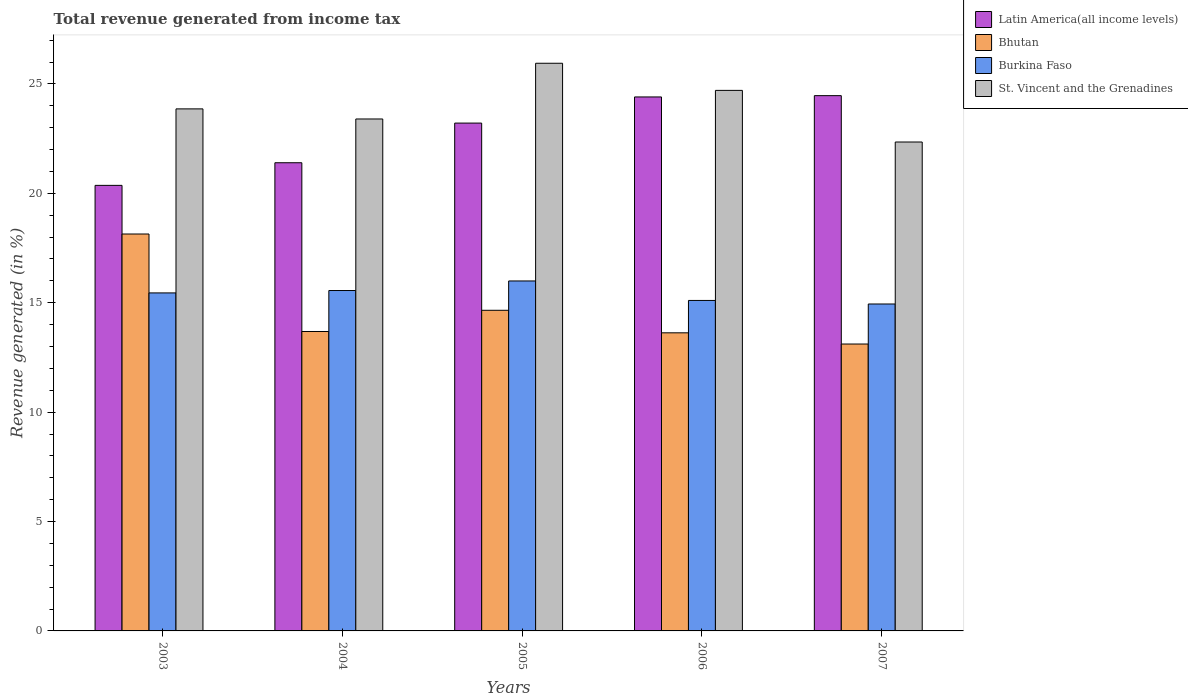How many different coloured bars are there?
Give a very brief answer. 4. Are the number of bars per tick equal to the number of legend labels?
Your answer should be compact. Yes. How many bars are there on the 2nd tick from the left?
Make the answer very short. 4. How many bars are there on the 3rd tick from the right?
Give a very brief answer. 4. In how many cases, is the number of bars for a given year not equal to the number of legend labels?
Your answer should be very brief. 0. What is the total revenue generated in Bhutan in 2007?
Your answer should be very brief. 13.11. Across all years, what is the maximum total revenue generated in Bhutan?
Your answer should be compact. 18.14. Across all years, what is the minimum total revenue generated in Burkina Faso?
Ensure brevity in your answer.  14.94. In which year was the total revenue generated in St. Vincent and the Grenadines maximum?
Make the answer very short. 2005. What is the total total revenue generated in Burkina Faso in the graph?
Your answer should be compact. 77.05. What is the difference between the total revenue generated in St. Vincent and the Grenadines in 2004 and that in 2005?
Give a very brief answer. -2.55. What is the difference between the total revenue generated in Burkina Faso in 2006 and the total revenue generated in St. Vincent and the Grenadines in 2004?
Ensure brevity in your answer.  -8.29. What is the average total revenue generated in Latin America(all income levels) per year?
Ensure brevity in your answer.  22.77. In the year 2004, what is the difference between the total revenue generated in Latin America(all income levels) and total revenue generated in St. Vincent and the Grenadines?
Ensure brevity in your answer.  -2. What is the ratio of the total revenue generated in Burkina Faso in 2004 to that in 2005?
Your response must be concise. 0.97. Is the difference between the total revenue generated in Latin America(all income levels) in 2003 and 2005 greater than the difference between the total revenue generated in St. Vincent and the Grenadines in 2003 and 2005?
Make the answer very short. No. What is the difference between the highest and the second highest total revenue generated in Latin America(all income levels)?
Ensure brevity in your answer.  0.06. What is the difference between the highest and the lowest total revenue generated in St. Vincent and the Grenadines?
Ensure brevity in your answer.  3.6. In how many years, is the total revenue generated in Bhutan greater than the average total revenue generated in Bhutan taken over all years?
Ensure brevity in your answer.  2. What does the 1st bar from the left in 2007 represents?
Keep it short and to the point. Latin America(all income levels). What does the 1st bar from the right in 2004 represents?
Your response must be concise. St. Vincent and the Grenadines. How many bars are there?
Your response must be concise. 20. How many years are there in the graph?
Your answer should be compact. 5. Are the values on the major ticks of Y-axis written in scientific E-notation?
Ensure brevity in your answer.  No. How are the legend labels stacked?
Ensure brevity in your answer.  Vertical. What is the title of the graph?
Give a very brief answer. Total revenue generated from income tax. What is the label or title of the Y-axis?
Your response must be concise. Revenue generated (in %). What is the Revenue generated (in %) of Latin America(all income levels) in 2003?
Give a very brief answer. 20.36. What is the Revenue generated (in %) of Bhutan in 2003?
Your response must be concise. 18.14. What is the Revenue generated (in %) in Burkina Faso in 2003?
Make the answer very short. 15.45. What is the Revenue generated (in %) of St. Vincent and the Grenadines in 2003?
Keep it short and to the point. 23.86. What is the Revenue generated (in %) of Latin America(all income levels) in 2004?
Offer a very short reply. 21.4. What is the Revenue generated (in %) in Bhutan in 2004?
Provide a succinct answer. 13.69. What is the Revenue generated (in %) of Burkina Faso in 2004?
Offer a terse response. 15.56. What is the Revenue generated (in %) of St. Vincent and the Grenadines in 2004?
Keep it short and to the point. 23.4. What is the Revenue generated (in %) in Latin America(all income levels) in 2005?
Provide a short and direct response. 23.21. What is the Revenue generated (in %) of Bhutan in 2005?
Offer a very short reply. 14.65. What is the Revenue generated (in %) of Burkina Faso in 2005?
Offer a terse response. 16. What is the Revenue generated (in %) in St. Vincent and the Grenadines in 2005?
Make the answer very short. 25.95. What is the Revenue generated (in %) in Latin America(all income levels) in 2006?
Your answer should be very brief. 24.41. What is the Revenue generated (in %) of Bhutan in 2006?
Your response must be concise. 13.63. What is the Revenue generated (in %) in Burkina Faso in 2006?
Your response must be concise. 15.11. What is the Revenue generated (in %) of St. Vincent and the Grenadines in 2006?
Make the answer very short. 24.71. What is the Revenue generated (in %) in Latin America(all income levels) in 2007?
Ensure brevity in your answer.  24.47. What is the Revenue generated (in %) in Bhutan in 2007?
Provide a short and direct response. 13.11. What is the Revenue generated (in %) of Burkina Faso in 2007?
Your answer should be very brief. 14.94. What is the Revenue generated (in %) of St. Vincent and the Grenadines in 2007?
Your answer should be compact. 22.35. Across all years, what is the maximum Revenue generated (in %) in Latin America(all income levels)?
Provide a short and direct response. 24.47. Across all years, what is the maximum Revenue generated (in %) of Bhutan?
Offer a terse response. 18.14. Across all years, what is the maximum Revenue generated (in %) in Burkina Faso?
Ensure brevity in your answer.  16. Across all years, what is the maximum Revenue generated (in %) of St. Vincent and the Grenadines?
Your answer should be compact. 25.95. Across all years, what is the minimum Revenue generated (in %) of Latin America(all income levels)?
Ensure brevity in your answer.  20.36. Across all years, what is the minimum Revenue generated (in %) in Bhutan?
Provide a short and direct response. 13.11. Across all years, what is the minimum Revenue generated (in %) of Burkina Faso?
Your answer should be very brief. 14.94. Across all years, what is the minimum Revenue generated (in %) of St. Vincent and the Grenadines?
Your response must be concise. 22.35. What is the total Revenue generated (in %) of Latin America(all income levels) in the graph?
Your response must be concise. 113.85. What is the total Revenue generated (in %) in Bhutan in the graph?
Your response must be concise. 73.22. What is the total Revenue generated (in %) of Burkina Faso in the graph?
Keep it short and to the point. 77.05. What is the total Revenue generated (in %) of St. Vincent and the Grenadines in the graph?
Give a very brief answer. 120.26. What is the difference between the Revenue generated (in %) in Latin America(all income levels) in 2003 and that in 2004?
Your response must be concise. -1.03. What is the difference between the Revenue generated (in %) of Bhutan in 2003 and that in 2004?
Ensure brevity in your answer.  4.46. What is the difference between the Revenue generated (in %) in Burkina Faso in 2003 and that in 2004?
Your answer should be very brief. -0.11. What is the difference between the Revenue generated (in %) in St. Vincent and the Grenadines in 2003 and that in 2004?
Offer a terse response. 0.46. What is the difference between the Revenue generated (in %) of Latin America(all income levels) in 2003 and that in 2005?
Offer a very short reply. -2.85. What is the difference between the Revenue generated (in %) of Bhutan in 2003 and that in 2005?
Provide a succinct answer. 3.49. What is the difference between the Revenue generated (in %) of Burkina Faso in 2003 and that in 2005?
Your response must be concise. -0.55. What is the difference between the Revenue generated (in %) of St. Vincent and the Grenadines in 2003 and that in 2005?
Ensure brevity in your answer.  -2.09. What is the difference between the Revenue generated (in %) of Latin America(all income levels) in 2003 and that in 2006?
Ensure brevity in your answer.  -4.04. What is the difference between the Revenue generated (in %) in Bhutan in 2003 and that in 2006?
Ensure brevity in your answer.  4.52. What is the difference between the Revenue generated (in %) of Burkina Faso in 2003 and that in 2006?
Keep it short and to the point. 0.34. What is the difference between the Revenue generated (in %) in St. Vincent and the Grenadines in 2003 and that in 2006?
Provide a short and direct response. -0.84. What is the difference between the Revenue generated (in %) of Latin America(all income levels) in 2003 and that in 2007?
Your answer should be very brief. -4.1. What is the difference between the Revenue generated (in %) of Bhutan in 2003 and that in 2007?
Offer a very short reply. 5.03. What is the difference between the Revenue generated (in %) in Burkina Faso in 2003 and that in 2007?
Offer a very short reply. 0.51. What is the difference between the Revenue generated (in %) of St. Vincent and the Grenadines in 2003 and that in 2007?
Your response must be concise. 1.51. What is the difference between the Revenue generated (in %) in Latin America(all income levels) in 2004 and that in 2005?
Ensure brevity in your answer.  -1.81. What is the difference between the Revenue generated (in %) in Bhutan in 2004 and that in 2005?
Give a very brief answer. -0.97. What is the difference between the Revenue generated (in %) of Burkina Faso in 2004 and that in 2005?
Keep it short and to the point. -0.44. What is the difference between the Revenue generated (in %) in St. Vincent and the Grenadines in 2004 and that in 2005?
Make the answer very short. -2.55. What is the difference between the Revenue generated (in %) of Latin America(all income levels) in 2004 and that in 2006?
Provide a succinct answer. -3.01. What is the difference between the Revenue generated (in %) of Bhutan in 2004 and that in 2006?
Make the answer very short. 0.06. What is the difference between the Revenue generated (in %) in Burkina Faso in 2004 and that in 2006?
Your answer should be very brief. 0.45. What is the difference between the Revenue generated (in %) of St. Vincent and the Grenadines in 2004 and that in 2006?
Offer a terse response. -1.31. What is the difference between the Revenue generated (in %) in Latin America(all income levels) in 2004 and that in 2007?
Your answer should be very brief. -3.07. What is the difference between the Revenue generated (in %) of Bhutan in 2004 and that in 2007?
Ensure brevity in your answer.  0.57. What is the difference between the Revenue generated (in %) in Burkina Faso in 2004 and that in 2007?
Provide a short and direct response. 0.62. What is the difference between the Revenue generated (in %) of St. Vincent and the Grenadines in 2004 and that in 2007?
Provide a short and direct response. 1.05. What is the difference between the Revenue generated (in %) in Latin America(all income levels) in 2005 and that in 2006?
Your answer should be compact. -1.19. What is the difference between the Revenue generated (in %) of Bhutan in 2005 and that in 2006?
Offer a very short reply. 1.03. What is the difference between the Revenue generated (in %) in Burkina Faso in 2005 and that in 2006?
Provide a short and direct response. 0.89. What is the difference between the Revenue generated (in %) of St. Vincent and the Grenadines in 2005 and that in 2006?
Provide a short and direct response. 1.24. What is the difference between the Revenue generated (in %) of Latin America(all income levels) in 2005 and that in 2007?
Ensure brevity in your answer.  -1.25. What is the difference between the Revenue generated (in %) in Bhutan in 2005 and that in 2007?
Your answer should be very brief. 1.54. What is the difference between the Revenue generated (in %) in Burkina Faso in 2005 and that in 2007?
Give a very brief answer. 1.05. What is the difference between the Revenue generated (in %) in St. Vincent and the Grenadines in 2005 and that in 2007?
Your answer should be very brief. 3.6. What is the difference between the Revenue generated (in %) of Latin America(all income levels) in 2006 and that in 2007?
Offer a very short reply. -0.06. What is the difference between the Revenue generated (in %) in Bhutan in 2006 and that in 2007?
Offer a terse response. 0.51. What is the difference between the Revenue generated (in %) of Burkina Faso in 2006 and that in 2007?
Provide a succinct answer. 0.16. What is the difference between the Revenue generated (in %) in St. Vincent and the Grenadines in 2006 and that in 2007?
Your response must be concise. 2.36. What is the difference between the Revenue generated (in %) of Latin America(all income levels) in 2003 and the Revenue generated (in %) of Bhutan in 2004?
Offer a very short reply. 6.68. What is the difference between the Revenue generated (in %) of Latin America(all income levels) in 2003 and the Revenue generated (in %) of Burkina Faso in 2004?
Your answer should be very brief. 4.81. What is the difference between the Revenue generated (in %) of Latin America(all income levels) in 2003 and the Revenue generated (in %) of St. Vincent and the Grenadines in 2004?
Provide a succinct answer. -3.03. What is the difference between the Revenue generated (in %) of Bhutan in 2003 and the Revenue generated (in %) of Burkina Faso in 2004?
Your answer should be compact. 2.58. What is the difference between the Revenue generated (in %) of Bhutan in 2003 and the Revenue generated (in %) of St. Vincent and the Grenadines in 2004?
Keep it short and to the point. -5.26. What is the difference between the Revenue generated (in %) in Burkina Faso in 2003 and the Revenue generated (in %) in St. Vincent and the Grenadines in 2004?
Offer a terse response. -7.95. What is the difference between the Revenue generated (in %) of Latin America(all income levels) in 2003 and the Revenue generated (in %) of Bhutan in 2005?
Your response must be concise. 5.71. What is the difference between the Revenue generated (in %) of Latin America(all income levels) in 2003 and the Revenue generated (in %) of Burkina Faso in 2005?
Provide a short and direct response. 4.37. What is the difference between the Revenue generated (in %) in Latin America(all income levels) in 2003 and the Revenue generated (in %) in St. Vincent and the Grenadines in 2005?
Offer a very short reply. -5.58. What is the difference between the Revenue generated (in %) of Bhutan in 2003 and the Revenue generated (in %) of Burkina Faso in 2005?
Offer a very short reply. 2.15. What is the difference between the Revenue generated (in %) in Bhutan in 2003 and the Revenue generated (in %) in St. Vincent and the Grenadines in 2005?
Make the answer very short. -7.8. What is the difference between the Revenue generated (in %) in Burkina Faso in 2003 and the Revenue generated (in %) in St. Vincent and the Grenadines in 2005?
Keep it short and to the point. -10.5. What is the difference between the Revenue generated (in %) of Latin America(all income levels) in 2003 and the Revenue generated (in %) of Bhutan in 2006?
Provide a succinct answer. 6.74. What is the difference between the Revenue generated (in %) of Latin America(all income levels) in 2003 and the Revenue generated (in %) of Burkina Faso in 2006?
Ensure brevity in your answer.  5.26. What is the difference between the Revenue generated (in %) of Latin America(all income levels) in 2003 and the Revenue generated (in %) of St. Vincent and the Grenadines in 2006?
Ensure brevity in your answer.  -4.34. What is the difference between the Revenue generated (in %) in Bhutan in 2003 and the Revenue generated (in %) in Burkina Faso in 2006?
Make the answer very short. 3.04. What is the difference between the Revenue generated (in %) of Bhutan in 2003 and the Revenue generated (in %) of St. Vincent and the Grenadines in 2006?
Provide a short and direct response. -6.56. What is the difference between the Revenue generated (in %) in Burkina Faso in 2003 and the Revenue generated (in %) in St. Vincent and the Grenadines in 2006?
Give a very brief answer. -9.26. What is the difference between the Revenue generated (in %) in Latin America(all income levels) in 2003 and the Revenue generated (in %) in Bhutan in 2007?
Provide a succinct answer. 7.25. What is the difference between the Revenue generated (in %) in Latin America(all income levels) in 2003 and the Revenue generated (in %) in Burkina Faso in 2007?
Ensure brevity in your answer.  5.42. What is the difference between the Revenue generated (in %) in Latin America(all income levels) in 2003 and the Revenue generated (in %) in St. Vincent and the Grenadines in 2007?
Provide a succinct answer. -1.98. What is the difference between the Revenue generated (in %) in Bhutan in 2003 and the Revenue generated (in %) in Burkina Faso in 2007?
Your response must be concise. 3.2. What is the difference between the Revenue generated (in %) in Bhutan in 2003 and the Revenue generated (in %) in St. Vincent and the Grenadines in 2007?
Your answer should be compact. -4.21. What is the difference between the Revenue generated (in %) of Burkina Faso in 2003 and the Revenue generated (in %) of St. Vincent and the Grenadines in 2007?
Offer a very short reply. -6.9. What is the difference between the Revenue generated (in %) of Latin America(all income levels) in 2004 and the Revenue generated (in %) of Bhutan in 2005?
Provide a succinct answer. 6.74. What is the difference between the Revenue generated (in %) of Latin America(all income levels) in 2004 and the Revenue generated (in %) of Burkina Faso in 2005?
Give a very brief answer. 5.4. What is the difference between the Revenue generated (in %) in Latin America(all income levels) in 2004 and the Revenue generated (in %) in St. Vincent and the Grenadines in 2005?
Offer a very short reply. -4.55. What is the difference between the Revenue generated (in %) in Bhutan in 2004 and the Revenue generated (in %) in Burkina Faso in 2005?
Give a very brief answer. -2.31. What is the difference between the Revenue generated (in %) in Bhutan in 2004 and the Revenue generated (in %) in St. Vincent and the Grenadines in 2005?
Your response must be concise. -12.26. What is the difference between the Revenue generated (in %) in Burkina Faso in 2004 and the Revenue generated (in %) in St. Vincent and the Grenadines in 2005?
Make the answer very short. -10.39. What is the difference between the Revenue generated (in %) of Latin America(all income levels) in 2004 and the Revenue generated (in %) of Bhutan in 2006?
Offer a very short reply. 7.77. What is the difference between the Revenue generated (in %) in Latin America(all income levels) in 2004 and the Revenue generated (in %) in Burkina Faso in 2006?
Keep it short and to the point. 6.29. What is the difference between the Revenue generated (in %) of Latin America(all income levels) in 2004 and the Revenue generated (in %) of St. Vincent and the Grenadines in 2006?
Your answer should be compact. -3.31. What is the difference between the Revenue generated (in %) in Bhutan in 2004 and the Revenue generated (in %) in Burkina Faso in 2006?
Offer a terse response. -1.42. What is the difference between the Revenue generated (in %) in Bhutan in 2004 and the Revenue generated (in %) in St. Vincent and the Grenadines in 2006?
Provide a short and direct response. -11.02. What is the difference between the Revenue generated (in %) of Burkina Faso in 2004 and the Revenue generated (in %) of St. Vincent and the Grenadines in 2006?
Ensure brevity in your answer.  -9.15. What is the difference between the Revenue generated (in %) of Latin America(all income levels) in 2004 and the Revenue generated (in %) of Bhutan in 2007?
Ensure brevity in your answer.  8.29. What is the difference between the Revenue generated (in %) in Latin America(all income levels) in 2004 and the Revenue generated (in %) in Burkina Faso in 2007?
Make the answer very short. 6.46. What is the difference between the Revenue generated (in %) of Latin America(all income levels) in 2004 and the Revenue generated (in %) of St. Vincent and the Grenadines in 2007?
Keep it short and to the point. -0.95. What is the difference between the Revenue generated (in %) in Bhutan in 2004 and the Revenue generated (in %) in Burkina Faso in 2007?
Keep it short and to the point. -1.26. What is the difference between the Revenue generated (in %) in Bhutan in 2004 and the Revenue generated (in %) in St. Vincent and the Grenadines in 2007?
Give a very brief answer. -8.66. What is the difference between the Revenue generated (in %) in Burkina Faso in 2004 and the Revenue generated (in %) in St. Vincent and the Grenadines in 2007?
Your response must be concise. -6.79. What is the difference between the Revenue generated (in %) in Latin America(all income levels) in 2005 and the Revenue generated (in %) in Bhutan in 2006?
Make the answer very short. 9.59. What is the difference between the Revenue generated (in %) in Latin America(all income levels) in 2005 and the Revenue generated (in %) in Burkina Faso in 2006?
Make the answer very short. 8.11. What is the difference between the Revenue generated (in %) in Latin America(all income levels) in 2005 and the Revenue generated (in %) in St. Vincent and the Grenadines in 2006?
Give a very brief answer. -1.49. What is the difference between the Revenue generated (in %) in Bhutan in 2005 and the Revenue generated (in %) in Burkina Faso in 2006?
Offer a very short reply. -0.45. What is the difference between the Revenue generated (in %) of Bhutan in 2005 and the Revenue generated (in %) of St. Vincent and the Grenadines in 2006?
Provide a succinct answer. -10.05. What is the difference between the Revenue generated (in %) in Burkina Faso in 2005 and the Revenue generated (in %) in St. Vincent and the Grenadines in 2006?
Provide a short and direct response. -8.71. What is the difference between the Revenue generated (in %) in Latin America(all income levels) in 2005 and the Revenue generated (in %) in Bhutan in 2007?
Ensure brevity in your answer.  10.1. What is the difference between the Revenue generated (in %) of Latin America(all income levels) in 2005 and the Revenue generated (in %) of Burkina Faso in 2007?
Make the answer very short. 8.27. What is the difference between the Revenue generated (in %) of Latin America(all income levels) in 2005 and the Revenue generated (in %) of St. Vincent and the Grenadines in 2007?
Keep it short and to the point. 0.86. What is the difference between the Revenue generated (in %) of Bhutan in 2005 and the Revenue generated (in %) of Burkina Faso in 2007?
Your answer should be compact. -0.29. What is the difference between the Revenue generated (in %) of Bhutan in 2005 and the Revenue generated (in %) of St. Vincent and the Grenadines in 2007?
Offer a very short reply. -7.69. What is the difference between the Revenue generated (in %) of Burkina Faso in 2005 and the Revenue generated (in %) of St. Vincent and the Grenadines in 2007?
Make the answer very short. -6.35. What is the difference between the Revenue generated (in %) of Latin America(all income levels) in 2006 and the Revenue generated (in %) of Bhutan in 2007?
Your answer should be compact. 11.29. What is the difference between the Revenue generated (in %) of Latin America(all income levels) in 2006 and the Revenue generated (in %) of Burkina Faso in 2007?
Provide a succinct answer. 9.46. What is the difference between the Revenue generated (in %) in Latin America(all income levels) in 2006 and the Revenue generated (in %) in St. Vincent and the Grenadines in 2007?
Make the answer very short. 2.06. What is the difference between the Revenue generated (in %) of Bhutan in 2006 and the Revenue generated (in %) of Burkina Faso in 2007?
Provide a short and direct response. -1.32. What is the difference between the Revenue generated (in %) in Bhutan in 2006 and the Revenue generated (in %) in St. Vincent and the Grenadines in 2007?
Provide a short and direct response. -8.72. What is the difference between the Revenue generated (in %) in Burkina Faso in 2006 and the Revenue generated (in %) in St. Vincent and the Grenadines in 2007?
Provide a short and direct response. -7.24. What is the average Revenue generated (in %) of Latin America(all income levels) per year?
Offer a terse response. 22.77. What is the average Revenue generated (in %) in Bhutan per year?
Your answer should be very brief. 14.64. What is the average Revenue generated (in %) of Burkina Faso per year?
Provide a short and direct response. 15.41. What is the average Revenue generated (in %) in St. Vincent and the Grenadines per year?
Offer a terse response. 24.05. In the year 2003, what is the difference between the Revenue generated (in %) of Latin America(all income levels) and Revenue generated (in %) of Bhutan?
Your answer should be very brief. 2.22. In the year 2003, what is the difference between the Revenue generated (in %) in Latin America(all income levels) and Revenue generated (in %) in Burkina Faso?
Your answer should be very brief. 4.92. In the year 2003, what is the difference between the Revenue generated (in %) in Latin America(all income levels) and Revenue generated (in %) in St. Vincent and the Grenadines?
Provide a succinct answer. -3.5. In the year 2003, what is the difference between the Revenue generated (in %) in Bhutan and Revenue generated (in %) in Burkina Faso?
Ensure brevity in your answer.  2.69. In the year 2003, what is the difference between the Revenue generated (in %) of Bhutan and Revenue generated (in %) of St. Vincent and the Grenadines?
Offer a very short reply. -5.72. In the year 2003, what is the difference between the Revenue generated (in %) in Burkina Faso and Revenue generated (in %) in St. Vincent and the Grenadines?
Provide a succinct answer. -8.41. In the year 2004, what is the difference between the Revenue generated (in %) in Latin America(all income levels) and Revenue generated (in %) in Bhutan?
Your response must be concise. 7.71. In the year 2004, what is the difference between the Revenue generated (in %) in Latin America(all income levels) and Revenue generated (in %) in Burkina Faso?
Your answer should be very brief. 5.84. In the year 2004, what is the difference between the Revenue generated (in %) of Latin America(all income levels) and Revenue generated (in %) of St. Vincent and the Grenadines?
Ensure brevity in your answer.  -2. In the year 2004, what is the difference between the Revenue generated (in %) in Bhutan and Revenue generated (in %) in Burkina Faso?
Give a very brief answer. -1.87. In the year 2004, what is the difference between the Revenue generated (in %) in Bhutan and Revenue generated (in %) in St. Vincent and the Grenadines?
Make the answer very short. -9.71. In the year 2004, what is the difference between the Revenue generated (in %) in Burkina Faso and Revenue generated (in %) in St. Vincent and the Grenadines?
Provide a short and direct response. -7.84. In the year 2005, what is the difference between the Revenue generated (in %) in Latin America(all income levels) and Revenue generated (in %) in Bhutan?
Your answer should be very brief. 8.56. In the year 2005, what is the difference between the Revenue generated (in %) of Latin America(all income levels) and Revenue generated (in %) of Burkina Faso?
Provide a succinct answer. 7.22. In the year 2005, what is the difference between the Revenue generated (in %) of Latin America(all income levels) and Revenue generated (in %) of St. Vincent and the Grenadines?
Provide a succinct answer. -2.73. In the year 2005, what is the difference between the Revenue generated (in %) of Bhutan and Revenue generated (in %) of Burkina Faso?
Provide a succinct answer. -1.34. In the year 2005, what is the difference between the Revenue generated (in %) of Bhutan and Revenue generated (in %) of St. Vincent and the Grenadines?
Your answer should be compact. -11.29. In the year 2005, what is the difference between the Revenue generated (in %) of Burkina Faso and Revenue generated (in %) of St. Vincent and the Grenadines?
Provide a short and direct response. -9.95. In the year 2006, what is the difference between the Revenue generated (in %) in Latin America(all income levels) and Revenue generated (in %) in Bhutan?
Keep it short and to the point. 10.78. In the year 2006, what is the difference between the Revenue generated (in %) of Latin America(all income levels) and Revenue generated (in %) of Burkina Faso?
Ensure brevity in your answer.  9.3. In the year 2006, what is the difference between the Revenue generated (in %) of Latin America(all income levels) and Revenue generated (in %) of St. Vincent and the Grenadines?
Your answer should be compact. -0.3. In the year 2006, what is the difference between the Revenue generated (in %) of Bhutan and Revenue generated (in %) of Burkina Faso?
Offer a terse response. -1.48. In the year 2006, what is the difference between the Revenue generated (in %) in Bhutan and Revenue generated (in %) in St. Vincent and the Grenadines?
Offer a terse response. -11.08. In the year 2006, what is the difference between the Revenue generated (in %) of Burkina Faso and Revenue generated (in %) of St. Vincent and the Grenadines?
Your answer should be compact. -9.6. In the year 2007, what is the difference between the Revenue generated (in %) of Latin America(all income levels) and Revenue generated (in %) of Bhutan?
Provide a short and direct response. 11.35. In the year 2007, what is the difference between the Revenue generated (in %) in Latin America(all income levels) and Revenue generated (in %) in Burkina Faso?
Give a very brief answer. 9.52. In the year 2007, what is the difference between the Revenue generated (in %) in Latin America(all income levels) and Revenue generated (in %) in St. Vincent and the Grenadines?
Your response must be concise. 2.12. In the year 2007, what is the difference between the Revenue generated (in %) in Bhutan and Revenue generated (in %) in Burkina Faso?
Offer a terse response. -1.83. In the year 2007, what is the difference between the Revenue generated (in %) in Bhutan and Revenue generated (in %) in St. Vincent and the Grenadines?
Give a very brief answer. -9.23. In the year 2007, what is the difference between the Revenue generated (in %) in Burkina Faso and Revenue generated (in %) in St. Vincent and the Grenadines?
Your answer should be compact. -7.4. What is the ratio of the Revenue generated (in %) in Latin America(all income levels) in 2003 to that in 2004?
Make the answer very short. 0.95. What is the ratio of the Revenue generated (in %) of Bhutan in 2003 to that in 2004?
Your answer should be compact. 1.33. What is the ratio of the Revenue generated (in %) in St. Vincent and the Grenadines in 2003 to that in 2004?
Offer a terse response. 1.02. What is the ratio of the Revenue generated (in %) of Latin America(all income levels) in 2003 to that in 2005?
Provide a succinct answer. 0.88. What is the ratio of the Revenue generated (in %) in Bhutan in 2003 to that in 2005?
Your answer should be very brief. 1.24. What is the ratio of the Revenue generated (in %) of Burkina Faso in 2003 to that in 2005?
Ensure brevity in your answer.  0.97. What is the ratio of the Revenue generated (in %) of St. Vincent and the Grenadines in 2003 to that in 2005?
Your answer should be very brief. 0.92. What is the ratio of the Revenue generated (in %) of Latin America(all income levels) in 2003 to that in 2006?
Provide a succinct answer. 0.83. What is the ratio of the Revenue generated (in %) in Bhutan in 2003 to that in 2006?
Offer a terse response. 1.33. What is the ratio of the Revenue generated (in %) of Burkina Faso in 2003 to that in 2006?
Your answer should be compact. 1.02. What is the ratio of the Revenue generated (in %) in St. Vincent and the Grenadines in 2003 to that in 2006?
Offer a terse response. 0.97. What is the ratio of the Revenue generated (in %) of Latin America(all income levels) in 2003 to that in 2007?
Offer a terse response. 0.83. What is the ratio of the Revenue generated (in %) in Bhutan in 2003 to that in 2007?
Make the answer very short. 1.38. What is the ratio of the Revenue generated (in %) in Burkina Faso in 2003 to that in 2007?
Give a very brief answer. 1.03. What is the ratio of the Revenue generated (in %) of St. Vincent and the Grenadines in 2003 to that in 2007?
Ensure brevity in your answer.  1.07. What is the ratio of the Revenue generated (in %) in Latin America(all income levels) in 2004 to that in 2005?
Your answer should be compact. 0.92. What is the ratio of the Revenue generated (in %) of Bhutan in 2004 to that in 2005?
Give a very brief answer. 0.93. What is the ratio of the Revenue generated (in %) of Burkina Faso in 2004 to that in 2005?
Your answer should be very brief. 0.97. What is the ratio of the Revenue generated (in %) in St. Vincent and the Grenadines in 2004 to that in 2005?
Ensure brevity in your answer.  0.9. What is the ratio of the Revenue generated (in %) of Latin America(all income levels) in 2004 to that in 2006?
Make the answer very short. 0.88. What is the ratio of the Revenue generated (in %) in Burkina Faso in 2004 to that in 2006?
Offer a terse response. 1.03. What is the ratio of the Revenue generated (in %) of St. Vincent and the Grenadines in 2004 to that in 2006?
Your answer should be compact. 0.95. What is the ratio of the Revenue generated (in %) of Latin America(all income levels) in 2004 to that in 2007?
Keep it short and to the point. 0.87. What is the ratio of the Revenue generated (in %) of Bhutan in 2004 to that in 2007?
Your response must be concise. 1.04. What is the ratio of the Revenue generated (in %) in Burkina Faso in 2004 to that in 2007?
Ensure brevity in your answer.  1.04. What is the ratio of the Revenue generated (in %) of St. Vincent and the Grenadines in 2004 to that in 2007?
Your answer should be very brief. 1.05. What is the ratio of the Revenue generated (in %) of Latin America(all income levels) in 2005 to that in 2006?
Your response must be concise. 0.95. What is the ratio of the Revenue generated (in %) in Bhutan in 2005 to that in 2006?
Ensure brevity in your answer.  1.08. What is the ratio of the Revenue generated (in %) of Burkina Faso in 2005 to that in 2006?
Keep it short and to the point. 1.06. What is the ratio of the Revenue generated (in %) in St. Vincent and the Grenadines in 2005 to that in 2006?
Your answer should be very brief. 1.05. What is the ratio of the Revenue generated (in %) in Latin America(all income levels) in 2005 to that in 2007?
Your answer should be compact. 0.95. What is the ratio of the Revenue generated (in %) in Bhutan in 2005 to that in 2007?
Offer a very short reply. 1.12. What is the ratio of the Revenue generated (in %) in Burkina Faso in 2005 to that in 2007?
Provide a short and direct response. 1.07. What is the ratio of the Revenue generated (in %) in St. Vincent and the Grenadines in 2005 to that in 2007?
Offer a very short reply. 1.16. What is the ratio of the Revenue generated (in %) in Latin America(all income levels) in 2006 to that in 2007?
Give a very brief answer. 1. What is the ratio of the Revenue generated (in %) in Bhutan in 2006 to that in 2007?
Keep it short and to the point. 1.04. What is the ratio of the Revenue generated (in %) in Burkina Faso in 2006 to that in 2007?
Provide a succinct answer. 1.01. What is the ratio of the Revenue generated (in %) of St. Vincent and the Grenadines in 2006 to that in 2007?
Your response must be concise. 1.11. What is the difference between the highest and the second highest Revenue generated (in %) of Latin America(all income levels)?
Offer a very short reply. 0.06. What is the difference between the highest and the second highest Revenue generated (in %) in Bhutan?
Ensure brevity in your answer.  3.49. What is the difference between the highest and the second highest Revenue generated (in %) of Burkina Faso?
Your answer should be very brief. 0.44. What is the difference between the highest and the second highest Revenue generated (in %) in St. Vincent and the Grenadines?
Your answer should be very brief. 1.24. What is the difference between the highest and the lowest Revenue generated (in %) in Latin America(all income levels)?
Offer a terse response. 4.1. What is the difference between the highest and the lowest Revenue generated (in %) of Bhutan?
Ensure brevity in your answer.  5.03. What is the difference between the highest and the lowest Revenue generated (in %) of Burkina Faso?
Give a very brief answer. 1.05. What is the difference between the highest and the lowest Revenue generated (in %) of St. Vincent and the Grenadines?
Your answer should be compact. 3.6. 